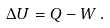<formula> <loc_0><loc_0><loc_500><loc_500>\Delta U = Q - W \, .</formula> 